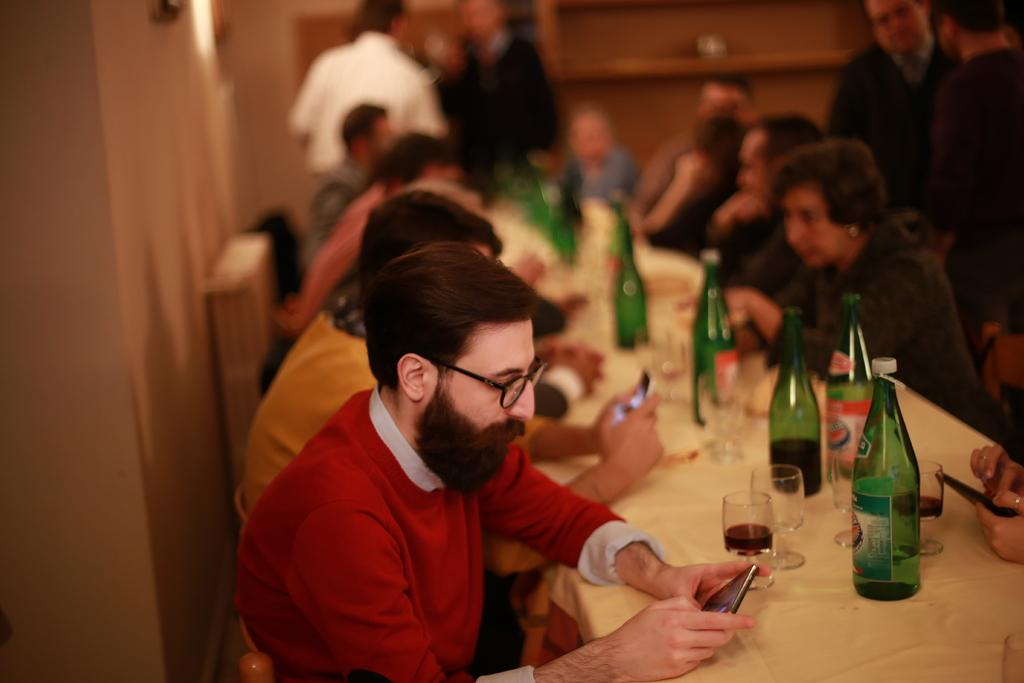How many people are in the image? There is a group of people in the image, but the exact number is not specified. What are the people doing in the image? The people are sitting in front of a table. What can be seen on the table in the image? There are bottles and other objects on the table. What type of sack can be seen in the image? There is no sack present in the image. What is the connection between the people in the image? The image does not provide information about any connections between the people. 